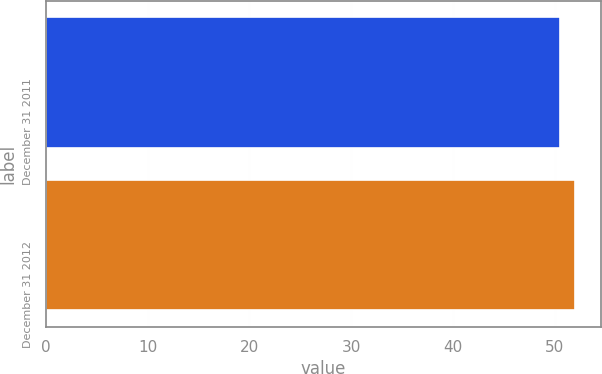Convert chart to OTSL. <chart><loc_0><loc_0><loc_500><loc_500><bar_chart><fcel>December 31 2011<fcel>December 31 2012<nl><fcel>50.52<fcel>51.98<nl></chart> 